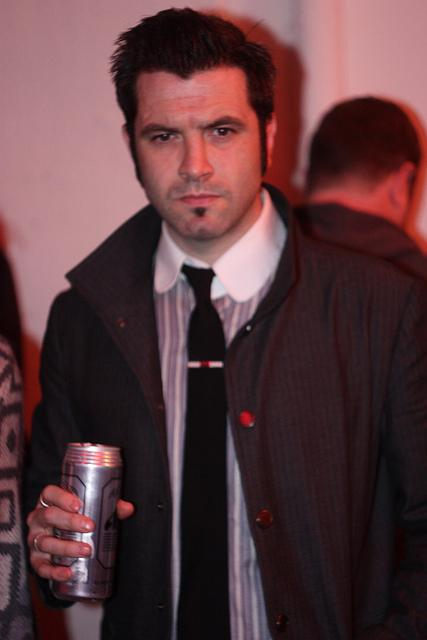How is the man holding the can feeling? angry 